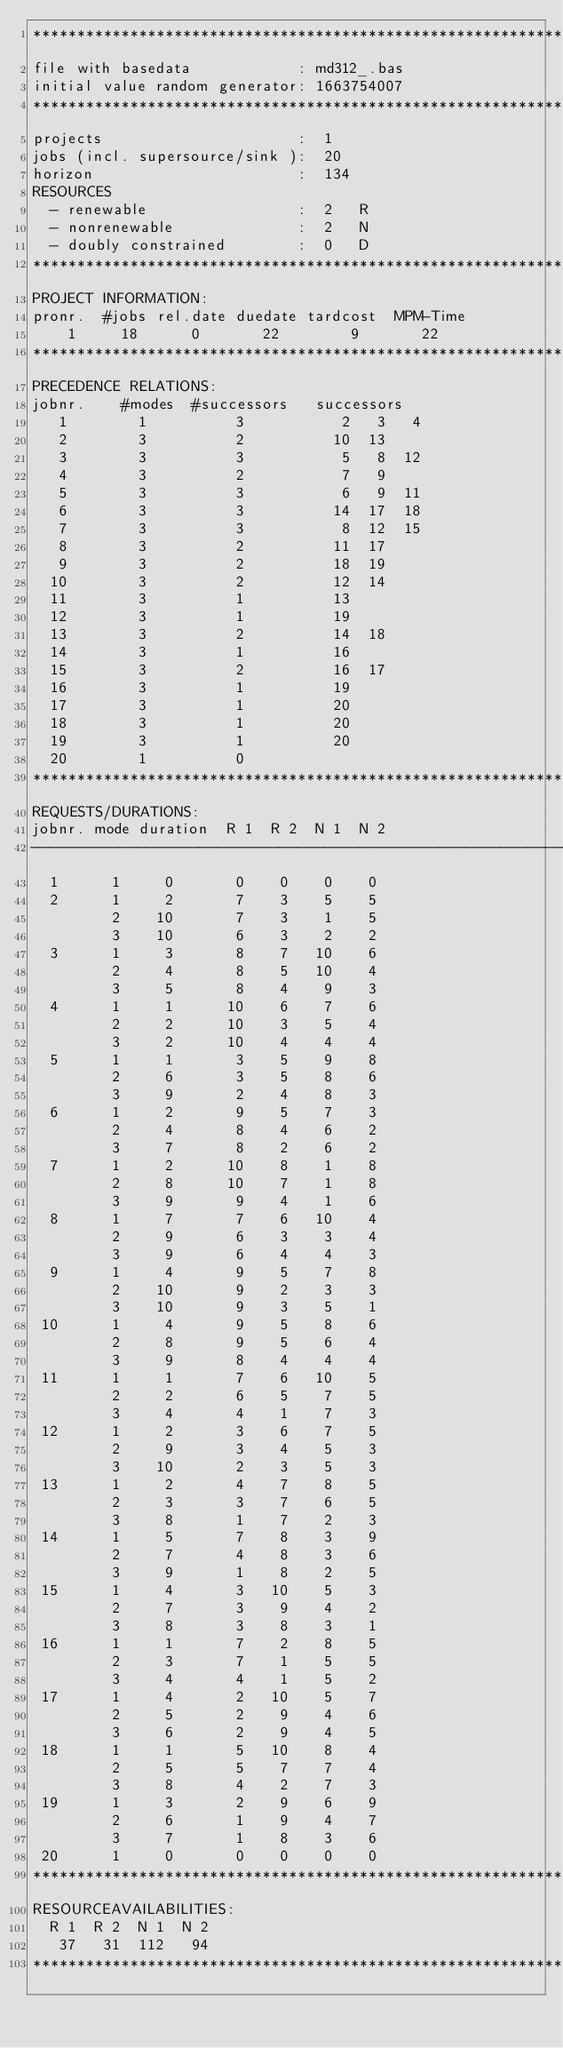<code> <loc_0><loc_0><loc_500><loc_500><_ObjectiveC_>************************************************************************
file with basedata            : md312_.bas
initial value random generator: 1663754007
************************************************************************
projects                      :  1
jobs (incl. supersource/sink ):  20
horizon                       :  134
RESOURCES
  - renewable                 :  2   R
  - nonrenewable              :  2   N
  - doubly constrained        :  0   D
************************************************************************
PROJECT INFORMATION:
pronr.  #jobs rel.date duedate tardcost  MPM-Time
    1     18      0       22        9       22
************************************************************************
PRECEDENCE RELATIONS:
jobnr.    #modes  #successors   successors
   1        1          3           2   3   4
   2        3          2          10  13
   3        3          3           5   8  12
   4        3          2           7   9
   5        3          3           6   9  11
   6        3          3          14  17  18
   7        3          3           8  12  15
   8        3          2          11  17
   9        3          2          18  19
  10        3          2          12  14
  11        3          1          13
  12        3          1          19
  13        3          2          14  18
  14        3          1          16
  15        3          2          16  17
  16        3          1          19
  17        3          1          20
  18        3          1          20
  19        3          1          20
  20        1          0        
************************************************************************
REQUESTS/DURATIONS:
jobnr. mode duration  R 1  R 2  N 1  N 2
------------------------------------------------------------------------
  1      1     0       0    0    0    0
  2      1     2       7    3    5    5
         2    10       7    3    1    5
         3    10       6    3    2    2
  3      1     3       8    7   10    6
         2     4       8    5   10    4
         3     5       8    4    9    3
  4      1     1      10    6    7    6
         2     2      10    3    5    4
         3     2      10    4    4    4
  5      1     1       3    5    9    8
         2     6       3    5    8    6
         3     9       2    4    8    3
  6      1     2       9    5    7    3
         2     4       8    4    6    2
         3     7       8    2    6    2
  7      1     2      10    8    1    8
         2     8      10    7    1    8
         3     9       9    4    1    6
  8      1     7       7    6   10    4
         2     9       6    3    3    4
         3     9       6    4    4    3
  9      1     4       9    5    7    8
         2    10       9    2    3    3
         3    10       9    3    5    1
 10      1     4       9    5    8    6
         2     8       9    5    6    4
         3     9       8    4    4    4
 11      1     1       7    6   10    5
         2     2       6    5    7    5
         3     4       4    1    7    3
 12      1     2       3    6    7    5
         2     9       3    4    5    3
         3    10       2    3    5    3
 13      1     2       4    7    8    5
         2     3       3    7    6    5
         3     8       1    7    2    3
 14      1     5       7    8    3    9
         2     7       4    8    3    6
         3     9       1    8    2    5
 15      1     4       3   10    5    3
         2     7       3    9    4    2
         3     8       3    8    3    1
 16      1     1       7    2    8    5
         2     3       7    1    5    5
         3     4       4    1    5    2
 17      1     4       2   10    5    7
         2     5       2    9    4    6
         3     6       2    9    4    5
 18      1     1       5   10    8    4
         2     5       5    7    7    4
         3     8       4    2    7    3
 19      1     3       2    9    6    9
         2     6       1    9    4    7
         3     7       1    8    3    6
 20      1     0       0    0    0    0
************************************************************************
RESOURCEAVAILABILITIES:
  R 1  R 2  N 1  N 2
   37   31  112   94
************************************************************************
</code> 